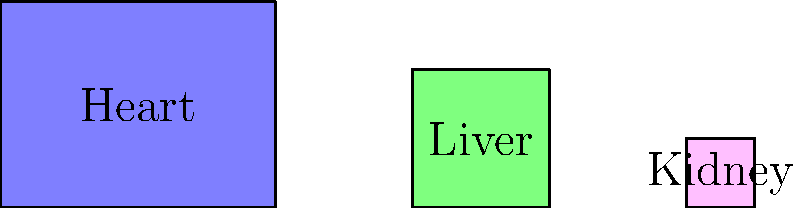In the diagram above, three congruent shapes represent different human organs: the heart, liver, and kidney. The shapes are scaled to represent the relative sizes of these organs. If the area of the shape representing the heart is 12 cm², what is the approximate area of the shape representing the kidney? Let's approach this step-by-step:

1) First, we need to understand what congruent shapes mean. Congruent shapes have the same shape and size, but may be rotated or reflected.

2) In this diagram, we see three rectangles representing the heart, liver, and kidney. The shapes are congruent, but scaled to represent the relative sizes of the organs.

3) We're given that the area of the heart shape is 12 cm².

4) To find the area of the kidney shape, we need to compare its size to the heart shape.

5) Looking at the diagram, we can see that:
   - The heart shape is the largest
   - The liver shape is slightly smaller
   - The kidney shape is the smallest

6) To estimate the area of the kidney shape, we need to visually compare it to the heart shape.

7) The kidney shape appears to be about 1/4 the size of the heart shape.

8) Since the area of the heart shape is 12 cm², we can estimate the area of the kidney shape as:

   $\text{Kidney Area} \approx \frac{1}{4} \times 12 \text{ cm}² = 3 \text{ cm}²$

Therefore, the approximate area of the shape representing the kidney is 3 cm².
Answer: 3 cm² 